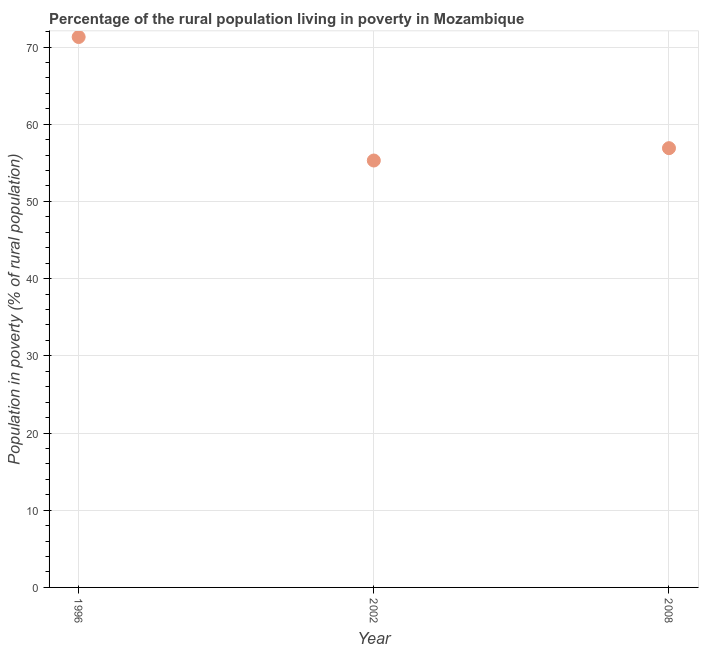What is the percentage of rural population living below poverty line in 2002?
Offer a terse response. 55.3. Across all years, what is the maximum percentage of rural population living below poverty line?
Your answer should be very brief. 71.3. Across all years, what is the minimum percentage of rural population living below poverty line?
Provide a succinct answer. 55.3. In which year was the percentage of rural population living below poverty line maximum?
Keep it short and to the point. 1996. In which year was the percentage of rural population living below poverty line minimum?
Your response must be concise. 2002. What is the sum of the percentage of rural population living below poverty line?
Offer a terse response. 183.5. What is the difference between the percentage of rural population living below poverty line in 2002 and 2008?
Offer a terse response. -1.6. What is the average percentage of rural population living below poverty line per year?
Offer a very short reply. 61.17. What is the median percentage of rural population living below poverty line?
Keep it short and to the point. 56.9. In how many years, is the percentage of rural population living below poverty line greater than 30 %?
Give a very brief answer. 3. What is the ratio of the percentage of rural population living below poverty line in 2002 to that in 2008?
Your answer should be very brief. 0.97. Is the percentage of rural population living below poverty line in 1996 less than that in 2008?
Make the answer very short. No. Is the difference between the percentage of rural population living below poverty line in 1996 and 2008 greater than the difference between any two years?
Your answer should be compact. No. What is the difference between the highest and the second highest percentage of rural population living below poverty line?
Offer a terse response. 14.4. What is the difference between two consecutive major ticks on the Y-axis?
Offer a very short reply. 10. Are the values on the major ticks of Y-axis written in scientific E-notation?
Offer a very short reply. No. Does the graph contain any zero values?
Give a very brief answer. No. Does the graph contain grids?
Make the answer very short. Yes. What is the title of the graph?
Your response must be concise. Percentage of the rural population living in poverty in Mozambique. What is the label or title of the X-axis?
Your answer should be very brief. Year. What is the label or title of the Y-axis?
Your answer should be compact. Population in poverty (% of rural population). What is the Population in poverty (% of rural population) in 1996?
Provide a short and direct response. 71.3. What is the Population in poverty (% of rural population) in 2002?
Make the answer very short. 55.3. What is the Population in poverty (% of rural population) in 2008?
Keep it short and to the point. 56.9. What is the ratio of the Population in poverty (% of rural population) in 1996 to that in 2002?
Your answer should be compact. 1.29. What is the ratio of the Population in poverty (% of rural population) in 1996 to that in 2008?
Offer a very short reply. 1.25. What is the ratio of the Population in poverty (% of rural population) in 2002 to that in 2008?
Your answer should be compact. 0.97. 